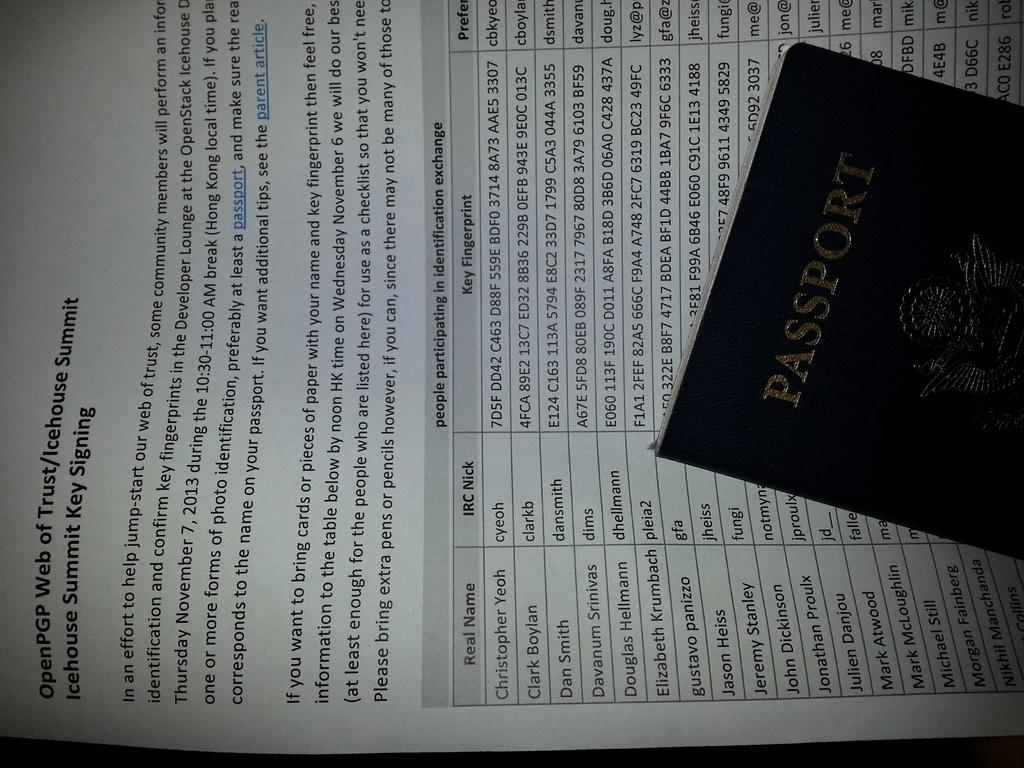<image>
Present a compact description of the photo's key features. A passport is resting on a piece of paper that says OpenPGP Web of Trust. 